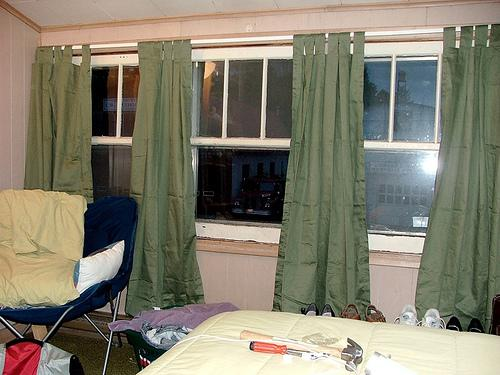What time of day is it likely to be? night 